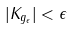Convert formula to latex. <formula><loc_0><loc_0><loc_500><loc_500>| K _ { g _ { \epsilon } } | < \epsilon</formula> 